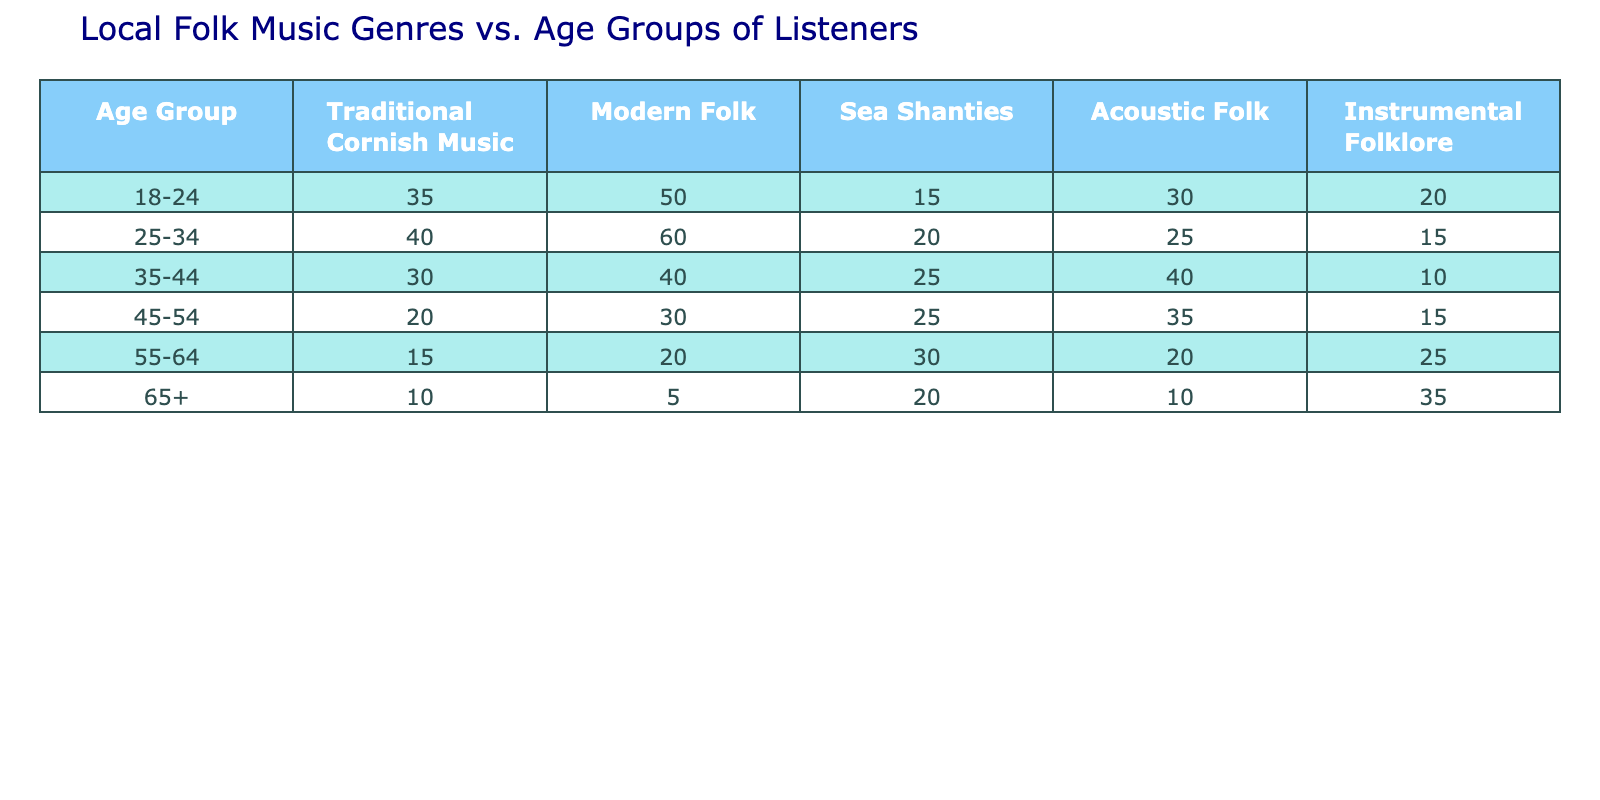What age group has the highest number of listeners for Traditional Cornish Music? By looking at the table, the highest number is 40, which corresponds to the 25-34 age group for Traditional Cornish Music.
Answer: 25-34 Which folk music genre is most popular among listeners aged 18-24? According to the table, for the age group 18-24, Modern Folk has the highest number of listeners at 50.
Answer: Modern Folk How many total listeners engage with Instrumental Folklore across all age groups? To find the total, we sum the values for Instrumental Folklore across all age groups: 20 + 15 + 10 + 15 + 25 + 35 = 130.
Answer: 130 Is there any age group that has more listeners for Sea Shanties than for Acoustic Folk? Yes, the age groups 35-44 and 55-64 have more listeners for Sea Shanties (25 and 30 respectively) compared to Acoustic Folk (40 and 20 respectively).
Answer: Yes What is the average number of listeners for Modern Folk across all age groups? We calculate the average by summing the values (50 + 60 + 40 + 30 + 20 + 5 = 205) and dividing by the number of age groups (6). Thus, 205/6 = 34.17, which rounds to approximately 34.
Answer: 34 What is the difference in the number of listeners for Traditional Cornish Music between the 18-24 and 45-54 age groups? The 18-24 age group has 35 listeners, while the 45-54 age group has 20 listeners. The difference is 35 - 20 = 15.
Answer: 15 Which genre has the least popularity among listeners aged 65 and above? From the table, the least popular genre for the 65+ age group is Modern Folk, with only 5 listeners.
Answer: Modern Folk How many listeners prefer Sea Shanties in total, and which age group contributes the most? The total number of listeners for Sea Shanties across all age groups is 15 + 20 + 25 + 25 + 30 + 20 = 125. The group 35-44 has the highest contribution with 25 listeners.
Answer: 125, 35-44 What is the highest number of listeners for Acoustic Folk among any age group? By checking the table, the maximum value for Acoustic Folk is 40, which is the number of listeners in the 35-44 age group.
Answer: 40 